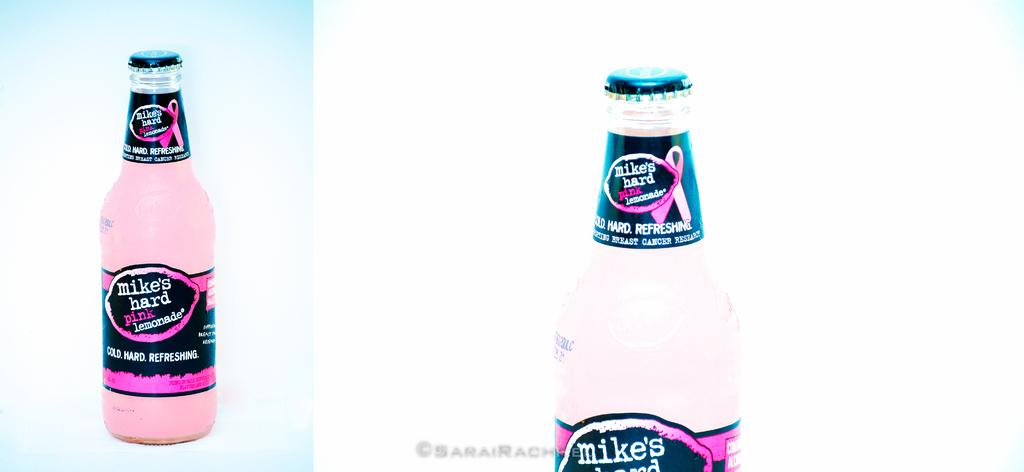<image>
Create a compact narrative representing the image presented. a bottle of Mikes Hard Lemonade with the cap still on 